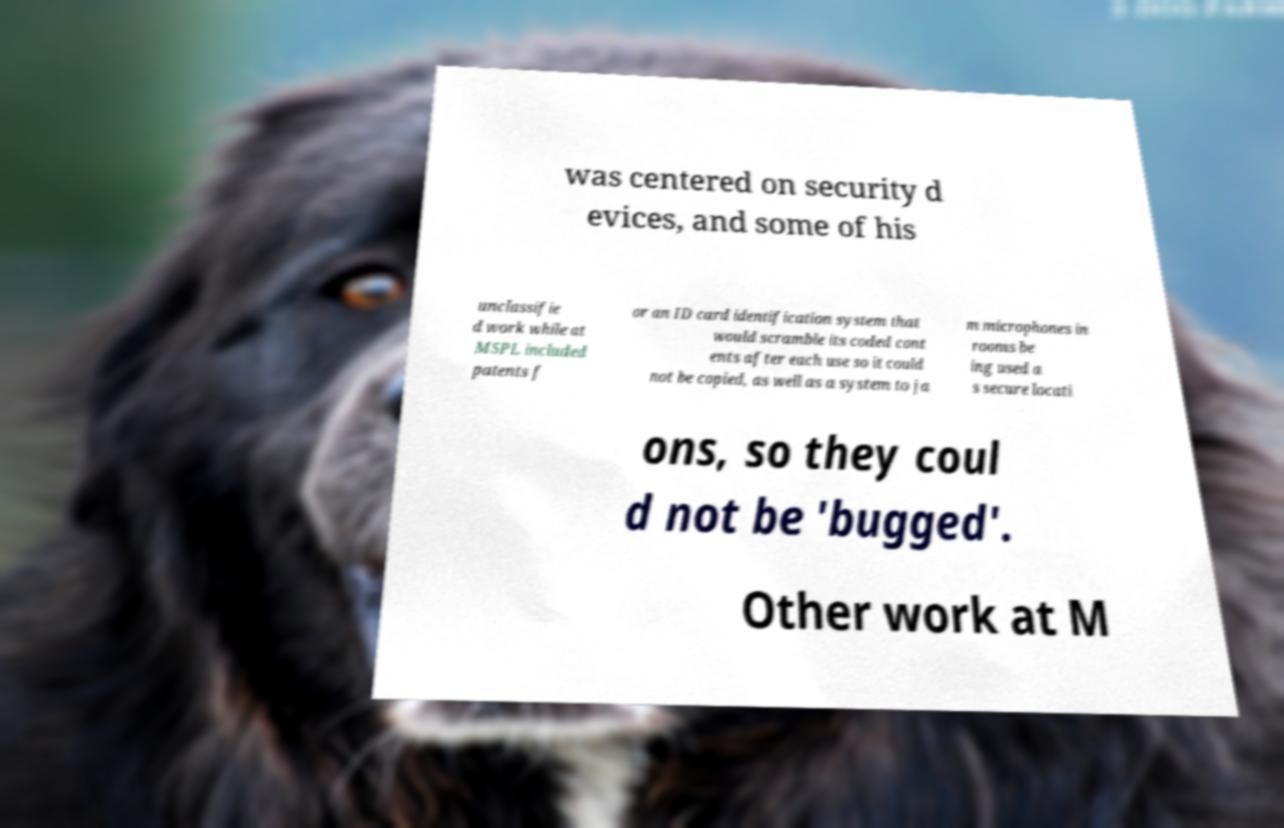There's text embedded in this image that I need extracted. Can you transcribe it verbatim? was centered on security d evices, and some of his unclassifie d work while at MSPL included patents f or an ID card identification system that would scramble its coded cont ents after each use so it could not be copied, as well as a system to ja m microphones in rooms be ing used a s secure locati ons, so they coul d not be 'bugged'. Other work at M 